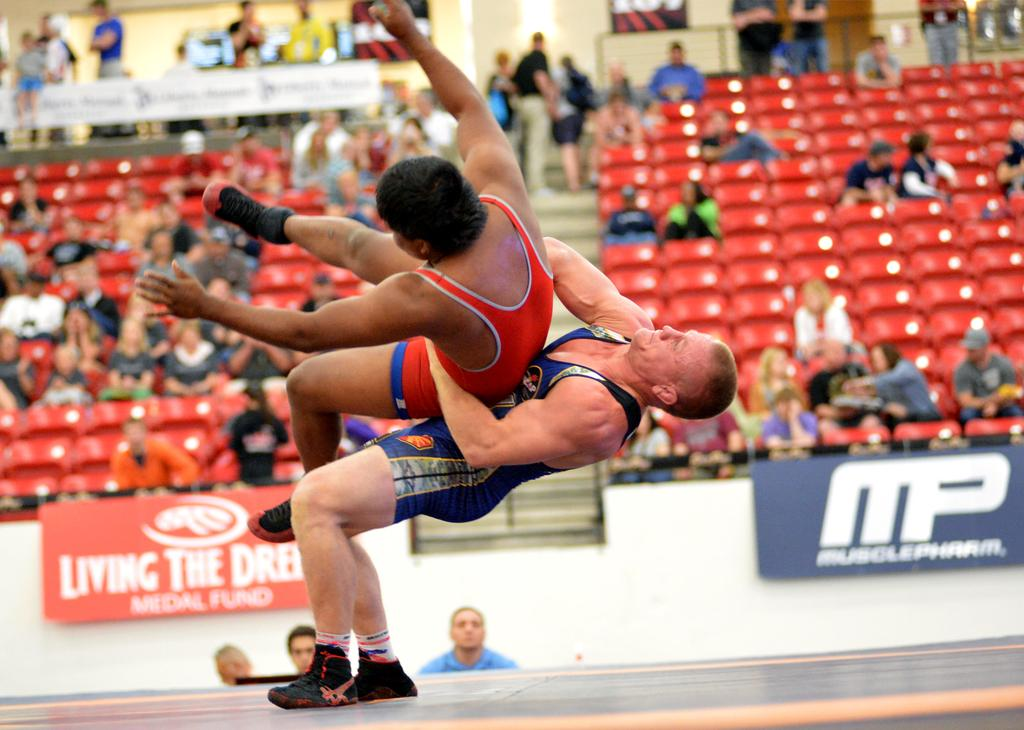What is the main action happening in the image? There is a person holding another person in the air. Can you describe the people in the background? The people in the background are likely serving as an audience. What type of skin condition can be seen on the person being held in the air? There is no indication of a skin condition on the person being held in the air, as the image does not show any visible skin issues. 